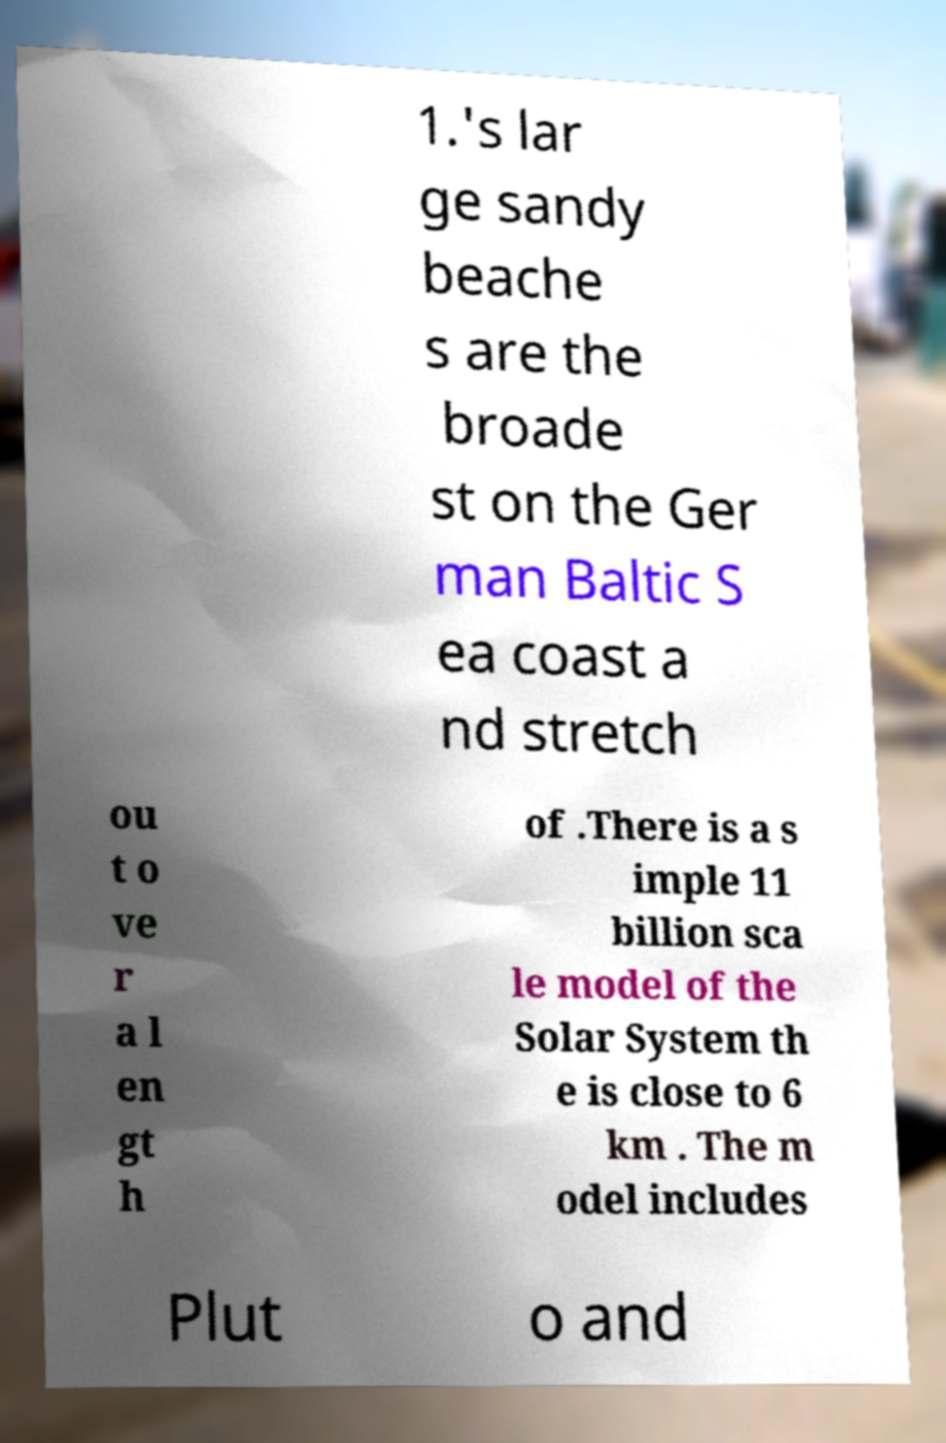I need the written content from this picture converted into text. Can you do that? 1.'s lar ge sandy beache s are the broade st on the Ger man Baltic S ea coast a nd stretch ou t o ve r a l en gt h of .There is a s imple 11 billion sca le model of the Solar System th e is close to 6 km . The m odel includes Plut o and 